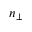Convert formula to latex. <formula><loc_0><loc_0><loc_500><loc_500>n _ { \perp }</formula> 